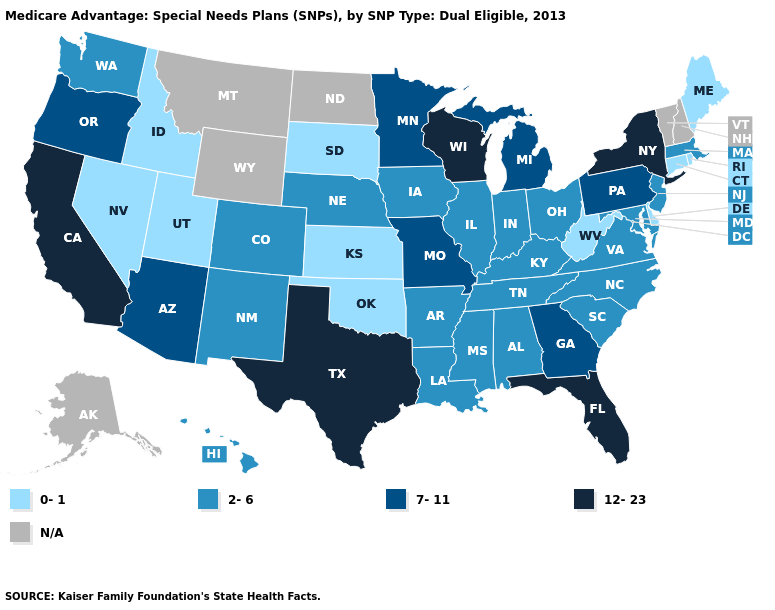Name the states that have a value in the range 12-23?
Quick response, please. California, Florida, New York, Texas, Wisconsin. Among the states that border California , does Nevada have the highest value?
Concise answer only. No. What is the value of Florida?
Write a very short answer. 12-23. What is the value of Georgia?
Give a very brief answer. 7-11. What is the lowest value in the USA?
Keep it brief. 0-1. Which states have the lowest value in the MidWest?
Give a very brief answer. Kansas, South Dakota. Does the map have missing data?
Answer briefly. Yes. Name the states that have a value in the range N/A?
Answer briefly. Alaska, Montana, North Dakota, New Hampshire, Vermont, Wyoming. Does the first symbol in the legend represent the smallest category?
Give a very brief answer. Yes. What is the value of Wyoming?
Quick response, please. N/A. Does Nevada have the lowest value in the West?
Write a very short answer. Yes. What is the value of Rhode Island?
Quick response, please. 0-1. Name the states that have a value in the range 0-1?
Keep it brief. Connecticut, Delaware, Idaho, Kansas, Maine, Nevada, Oklahoma, Rhode Island, South Dakota, Utah, West Virginia. Does Rhode Island have the lowest value in the Northeast?
Keep it brief. Yes. 